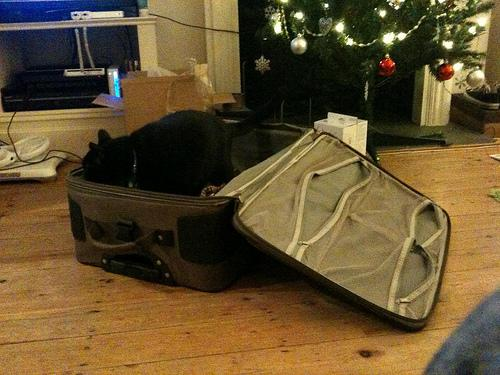Explain the interaction between the cat and any object or item in the image. The cat is sitting inside an open suitcase, interacting with the luggage, wearing a collar. What is a notable aspect about the cat in the image? The cat is wearing a collar and has black ears, sitting inside an open suitcase. Identify the main object occupying the most space in the given image and give a brief description. An open suitcase on its side, predominantly taking up space in the image, with contents inside it. 